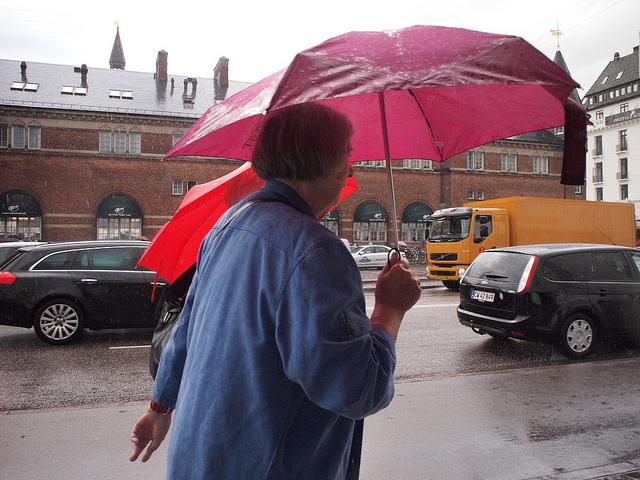Is this man afraid of the rain?
Be succinct. No. What color is the big truck?
Concise answer only. Yellow. Is the car trunk open?
Quick response, please. No. Is the picture in color?
Concise answer only. Yes. What color is the umbrella?
Answer briefly. Red. Is it a sunny day?
Concise answer only. No. How many umbrellas are in the photo?
Write a very short answer. 2. What color is the Umbrella?
Concise answer only. Pink. Where is the photographer sitting?
Answer briefly. Bench. What colors are the umbrellas?
Write a very short answer. Red. What color is the building?
Keep it brief. Red. Should the umbrella be replaced?
Give a very brief answer. No. What is the woman holding in her right hand?
Short answer required. Umbrella. Is the woman on a phone?
Write a very short answer. No. 